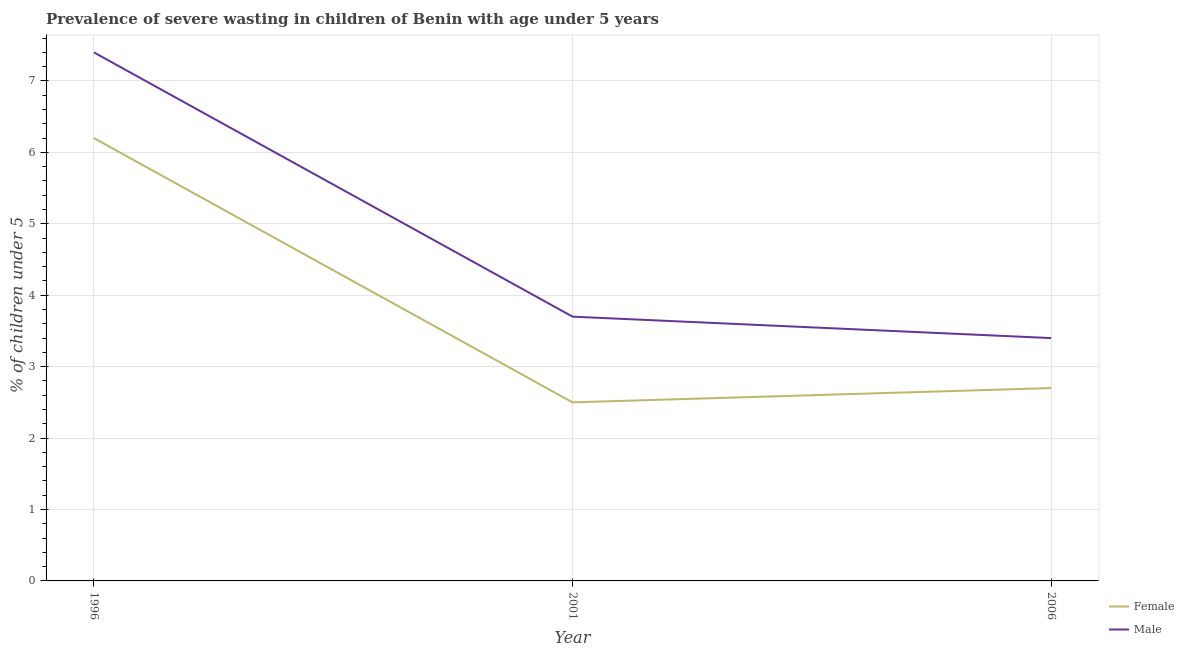How many different coloured lines are there?
Your answer should be very brief. 2. Does the line corresponding to percentage of undernourished male children intersect with the line corresponding to percentage of undernourished female children?
Your response must be concise. No. What is the percentage of undernourished male children in 2001?
Provide a succinct answer. 3.7. Across all years, what is the maximum percentage of undernourished female children?
Your answer should be compact. 6.2. Across all years, what is the minimum percentage of undernourished male children?
Offer a very short reply. 3.4. In which year was the percentage of undernourished male children maximum?
Make the answer very short. 1996. In which year was the percentage of undernourished male children minimum?
Make the answer very short. 2006. What is the total percentage of undernourished male children in the graph?
Provide a succinct answer. 14.5. What is the difference between the percentage of undernourished female children in 1996 and that in 2001?
Provide a succinct answer. 3.7. What is the difference between the percentage of undernourished male children in 1996 and the percentage of undernourished female children in 2001?
Your answer should be compact. 4.9. What is the average percentage of undernourished male children per year?
Ensure brevity in your answer.  4.83. In the year 1996, what is the difference between the percentage of undernourished male children and percentage of undernourished female children?
Your response must be concise. 1.2. What is the ratio of the percentage of undernourished female children in 2001 to that in 2006?
Ensure brevity in your answer.  0.93. Is the percentage of undernourished male children in 2001 less than that in 2006?
Offer a very short reply. No. Is the difference between the percentage of undernourished female children in 1996 and 2006 greater than the difference between the percentage of undernourished male children in 1996 and 2006?
Provide a short and direct response. No. What is the difference between the highest and the second highest percentage of undernourished female children?
Give a very brief answer. 3.5. What is the difference between the highest and the lowest percentage of undernourished male children?
Offer a very short reply. 4. In how many years, is the percentage of undernourished male children greater than the average percentage of undernourished male children taken over all years?
Your answer should be very brief. 1. Is the sum of the percentage of undernourished female children in 1996 and 2001 greater than the maximum percentage of undernourished male children across all years?
Your response must be concise. Yes. Is the percentage of undernourished female children strictly less than the percentage of undernourished male children over the years?
Give a very brief answer. Yes. How many years are there in the graph?
Give a very brief answer. 3. Are the values on the major ticks of Y-axis written in scientific E-notation?
Give a very brief answer. No. Where does the legend appear in the graph?
Offer a very short reply. Bottom right. What is the title of the graph?
Offer a terse response. Prevalence of severe wasting in children of Benin with age under 5 years. What is the label or title of the Y-axis?
Keep it short and to the point.  % of children under 5. What is the  % of children under 5 of Female in 1996?
Offer a terse response. 6.2. What is the  % of children under 5 of Male in 1996?
Your answer should be compact. 7.4. What is the  % of children under 5 of Male in 2001?
Your answer should be compact. 3.7. What is the  % of children under 5 in Female in 2006?
Provide a short and direct response. 2.7. What is the  % of children under 5 of Male in 2006?
Provide a succinct answer. 3.4. Across all years, what is the maximum  % of children under 5 in Female?
Keep it short and to the point. 6.2. Across all years, what is the maximum  % of children under 5 of Male?
Make the answer very short. 7.4. Across all years, what is the minimum  % of children under 5 of Female?
Your response must be concise. 2.5. Across all years, what is the minimum  % of children under 5 of Male?
Ensure brevity in your answer.  3.4. What is the difference between the  % of children under 5 of Male in 1996 and that in 2001?
Keep it short and to the point. 3.7. What is the difference between the  % of children under 5 in Female in 1996 and that in 2006?
Provide a succinct answer. 3.5. What is the difference between the  % of children under 5 of Male in 2001 and that in 2006?
Offer a very short reply. 0.3. What is the difference between the  % of children under 5 in Female in 1996 and the  % of children under 5 in Male in 2001?
Ensure brevity in your answer.  2.5. What is the difference between the  % of children under 5 of Female in 1996 and the  % of children under 5 of Male in 2006?
Make the answer very short. 2.8. What is the difference between the  % of children under 5 of Female in 2001 and the  % of children under 5 of Male in 2006?
Your response must be concise. -0.9. What is the average  % of children under 5 of Female per year?
Give a very brief answer. 3.8. What is the average  % of children under 5 of Male per year?
Provide a succinct answer. 4.83. In the year 1996, what is the difference between the  % of children under 5 of Female and  % of children under 5 of Male?
Provide a short and direct response. -1.2. In the year 2006, what is the difference between the  % of children under 5 of Female and  % of children under 5 of Male?
Your response must be concise. -0.7. What is the ratio of the  % of children under 5 in Female in 1996 to that in 2001?
Give a very brief answer. 2.48. What is the ratio of the  % of children under 5 of Female in 1996 to that in 2006?
Keep it short and to the point. 2.3. What is the ratio of the  % of children under 5 in Male in 1996 to that in 2006?
Your answer should be very brief. 2.18. What is the ratio of the  % of children under 5 in Female in 2001 to that in 2006?
Make the answer very short. 0.93. What is the ratio of the  % of children under 5 of Male in 2001 to that in 2006?
Offer a very short reply. 1.09. 